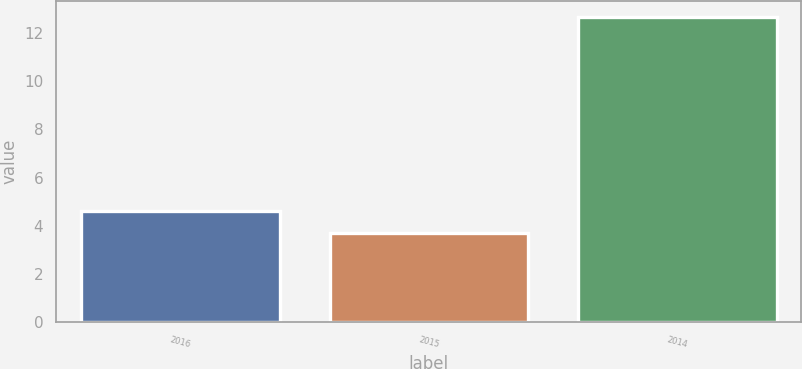<chart> <loc_0><loc_0><loc_500><loc_500><bar_chart><fcel>2016<fcel>2015<fcel>2014<nl><fcel>4.6<fcel>3.7<fcel>12.7<nl></chart> 